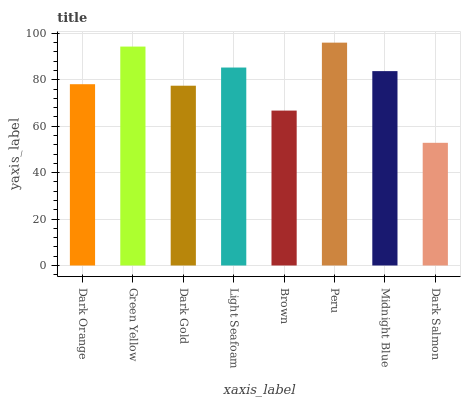Is Dark Salmon the minimum?
Answer yes or no. Yes. Is Peru the maximum?
Answer yes or no. Yes. Is Green Yellow the minimum?
Answer yes or no. No. Is Green Yellow the maximum?
Answer yes or no. No. Is Green Yellow greater than Dark Orange?
Answer yes or no. Yes. Is Dark Orange less than Green Yellow?
Answer yes or no. Yes. Is Dark Orange greater than Green Yellow?
Answer yes or no. No. Is Green Yellow less than Dark Orange?
Answer yes or no. No. Is Midnight Blue the high median?
Answer yes or no. Yes. Is Dark Orange the low median?
Answer yes or no. Yes. Is Green Yellow the high median?
Answer yes or no. No. Is Dark Gold the low median?
Answer yes or no. No. 